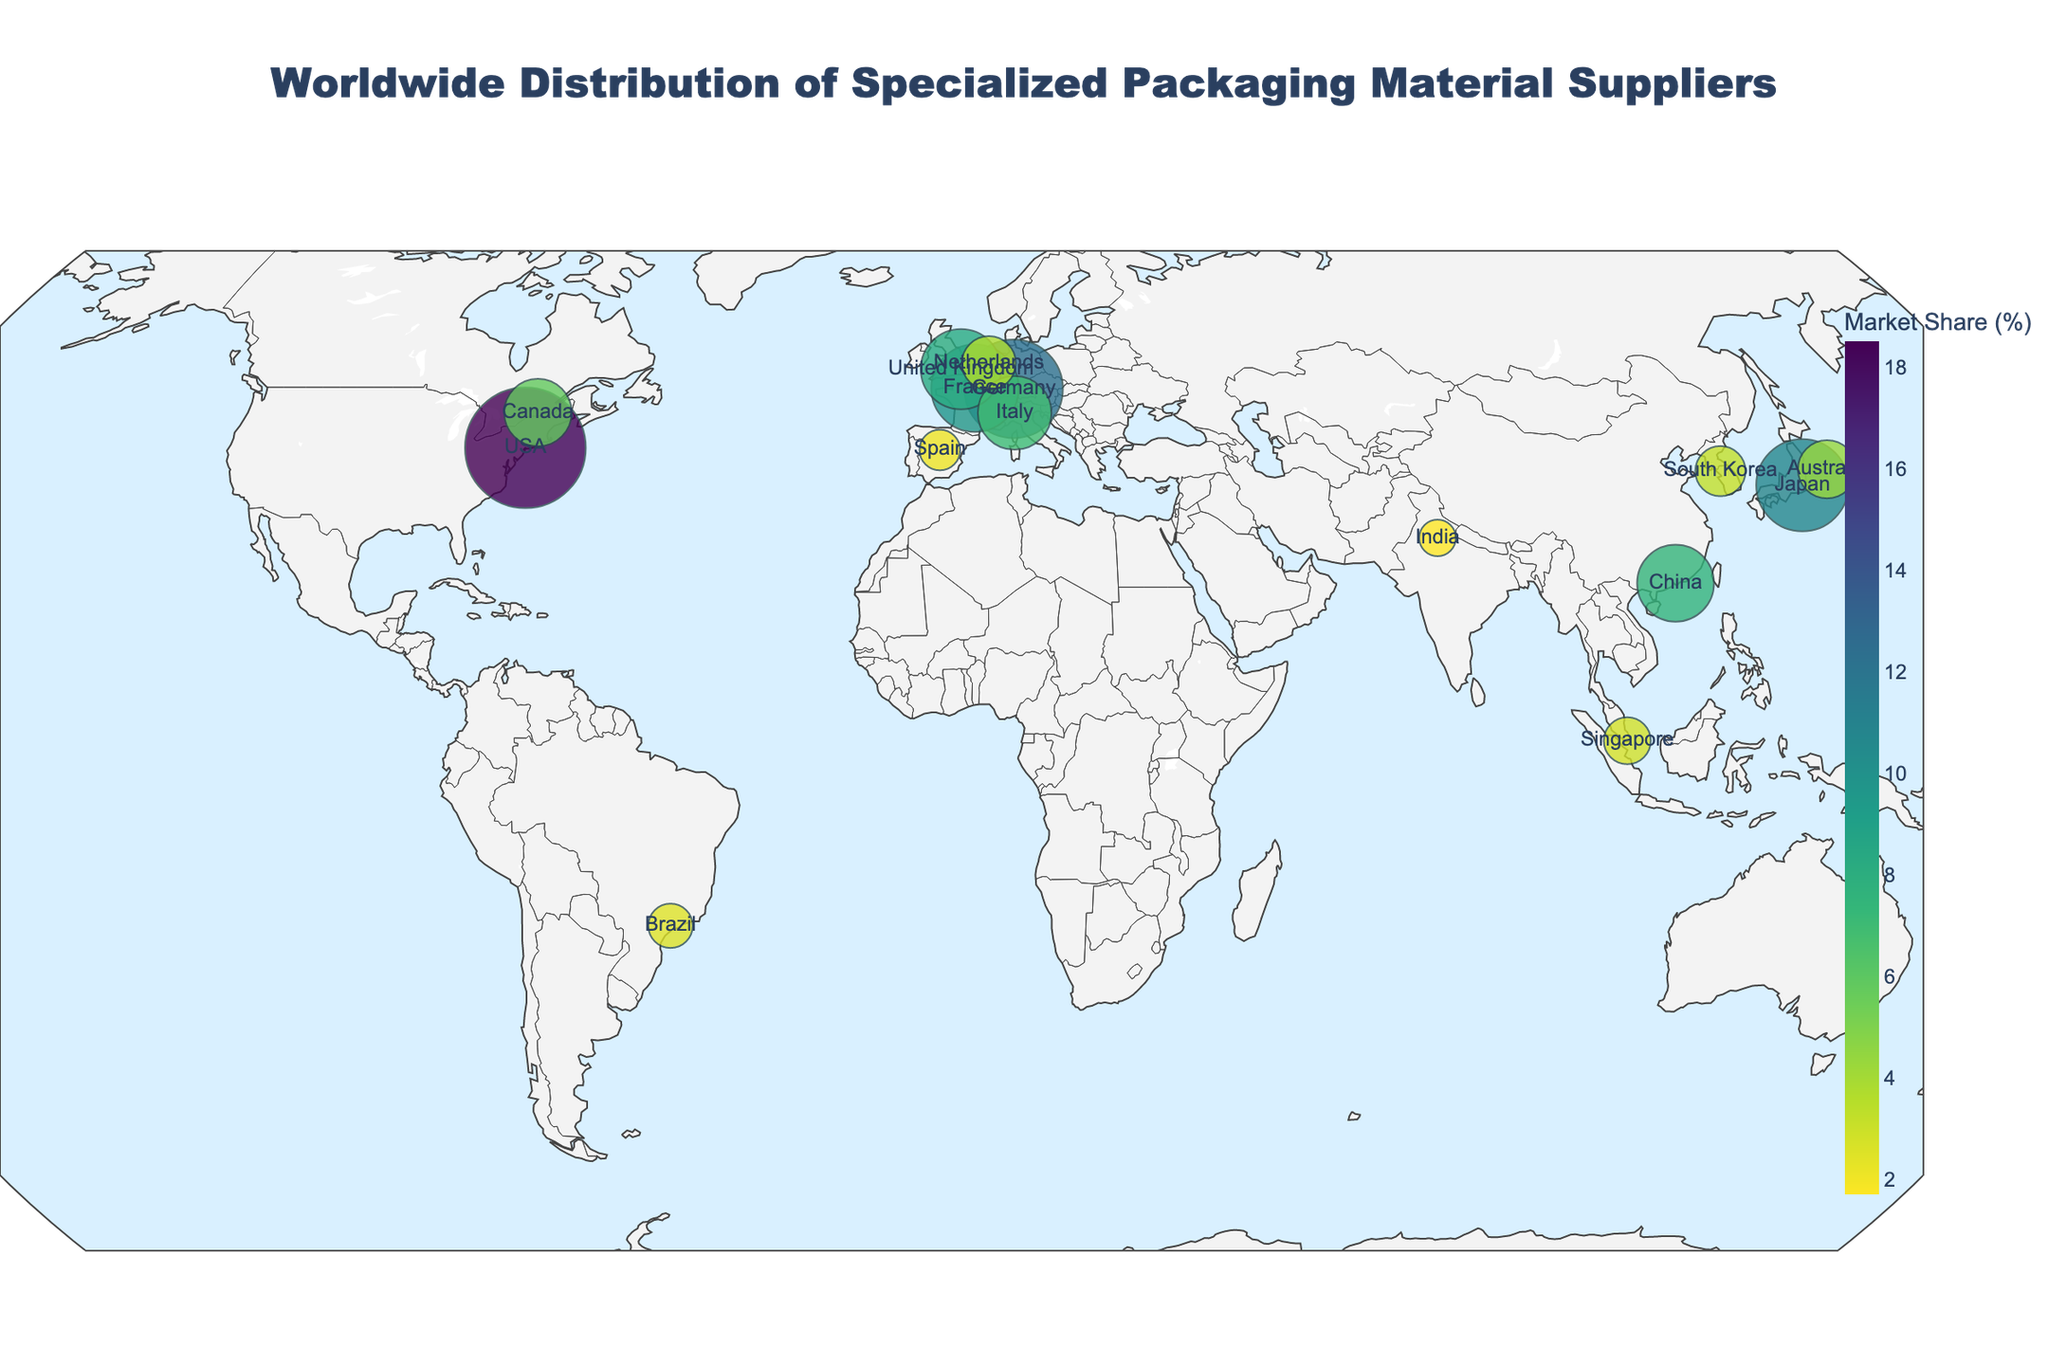What is the title of the plot? The title of the plot is located at the top center of the figure.
Answer: Worldwide Distribution of Specialized Packaging Material Suppliers How many companies are represented in the plot? By counting the number of data points (companies) on the plot, we get the total number.
Answer: 15 Which company has the largest market share? By observing the size of the markers on the plot, we identify the largest one.
Answer: Sealed Air Corporation Which two countries have markers that are closest to each other geographically? Looking closely at the geographic locations of the markers, check for proximity.
Answer: France and Germany What is the market share difference between the company with the highest and lowest market share? The highest market share is 18.5% (Sealed Air Corporation) and the lowest is 1.7% (Uflex Limited). The difference is calculated as 18.5 - 1.7.
Answer: 16.8% Which region of the world has the highest concentration of suppliers? Survey the geographic plot to identify regions with the densest cluster of markers.
Answer: Europe How many suppliers have a market share greater than 10%? Review the markers' sizes relative to the market share color gradient and legend. Identify the number surpassing 10%.
Answer: 3 What is the combined market share of companies located in Europe? Add the individual market shares of suppliers from Germany, France, United Kingdom, Italy, Netherlands, and Spain: 12.3 + 9.7 + 8.2 + 6.9 + 3.7 + 2.1
Answer: 42.9% Which company's marker is located closest to the equator? Identify the latitude of all markers and check which one is closest to 0° latitude.
Answer: Inno-Pak Solutions Pte Ltd What can be inferred about the distribution of suppliers in Asia? Observe the markers’ positions in Asia, noting the countries they are most prominent in and their relative market shares. Suppliers are located in Japan, China, South Korea, Singapore, and India with varying market shares.
Answer: Diverse distribution across several countries 